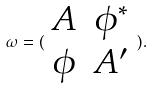Convert formula to latex. <formula><loc_0><loc_0><loc_500><loc_500>\omega = ( \begin{array} { c c } A & \phi ^ { * } \\ \phi & A ^ { \prime } \end{array} ) .</formula> 